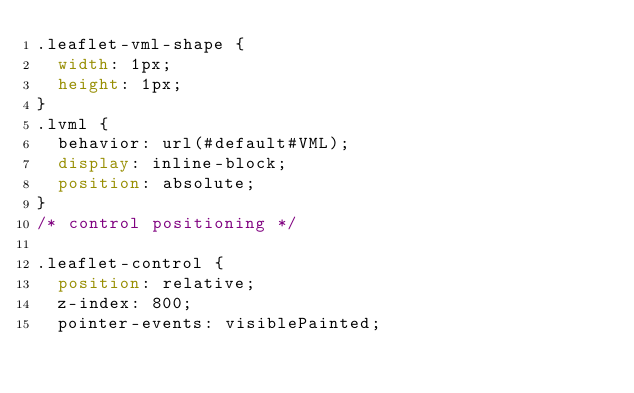Convert code to text. <code><loc_0><loc_0><loc_500><loc_500><_CSS_>.leaflet-vml-shape {
	width: 1px;
	height: 1px;
}
.lvml {
	behavior: url(#default#VML);
	display: inline-block;
	position: absolute;
}
/* control positioning */

.leaflet-control {
	position: relative;
	z-index: 800;
	pointer-events: visiblePainted;</code> 